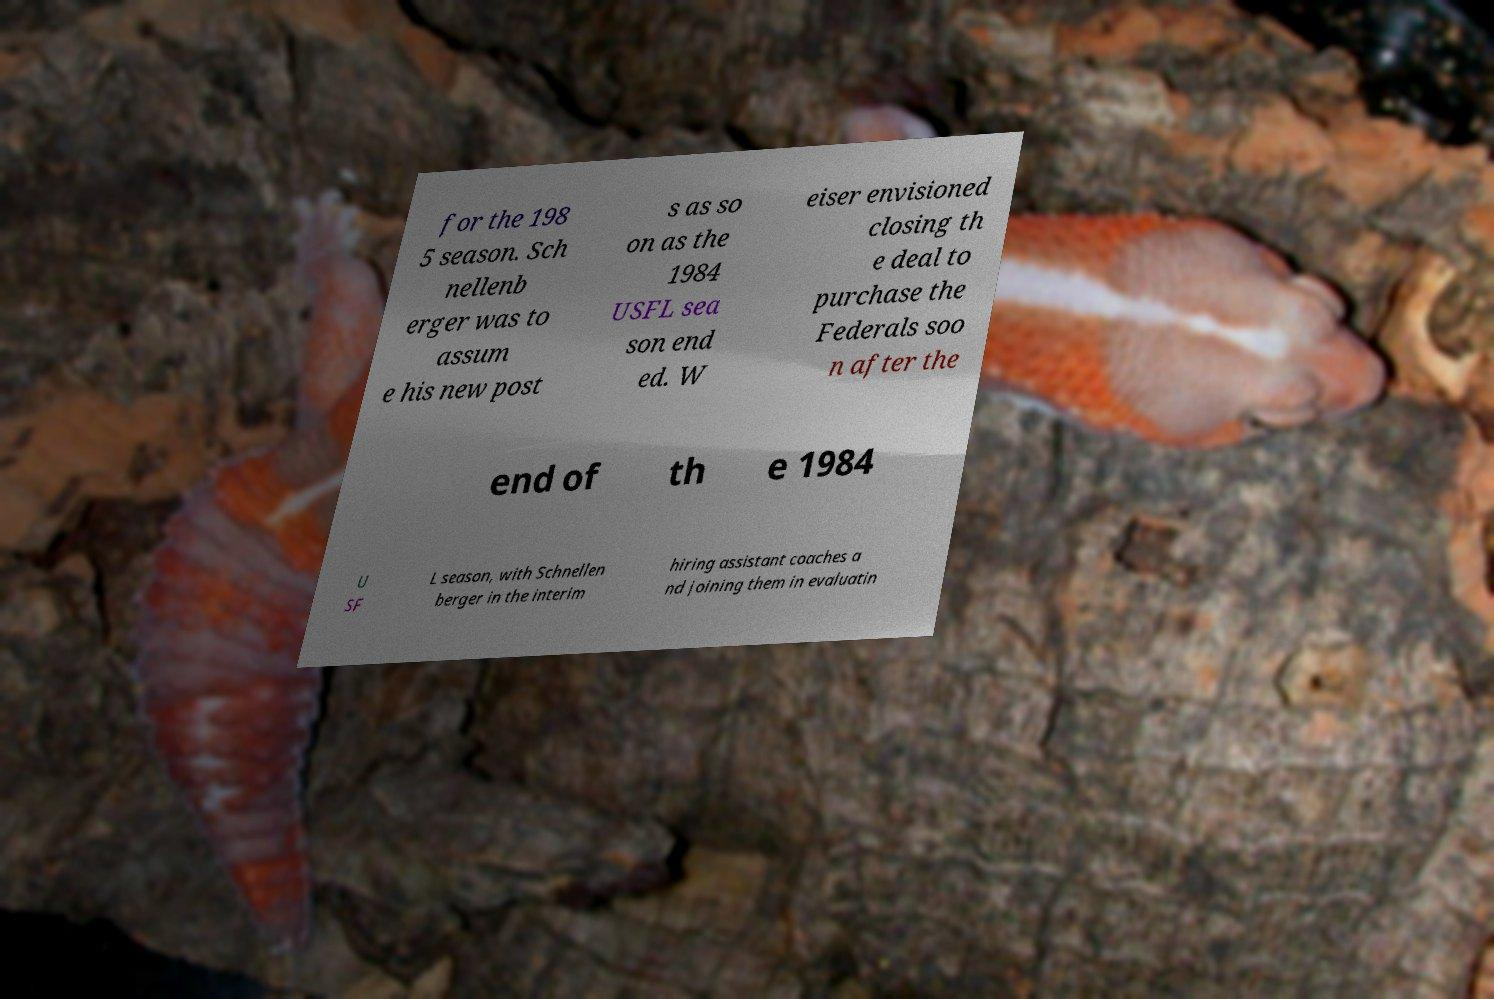Please identify and transcribe the text found in this image. for the 198 5 season. Sch nellenb erger was to assum e his new post s as so on as the 1984 USFL sea son end ed. W eiser envisioned closing th e deal to purchase the Federals soo n after the end of th e 1984 U SF L season, with Schnellen berger in the interim hiring assistant coaches a nd joining them in evaluatin 